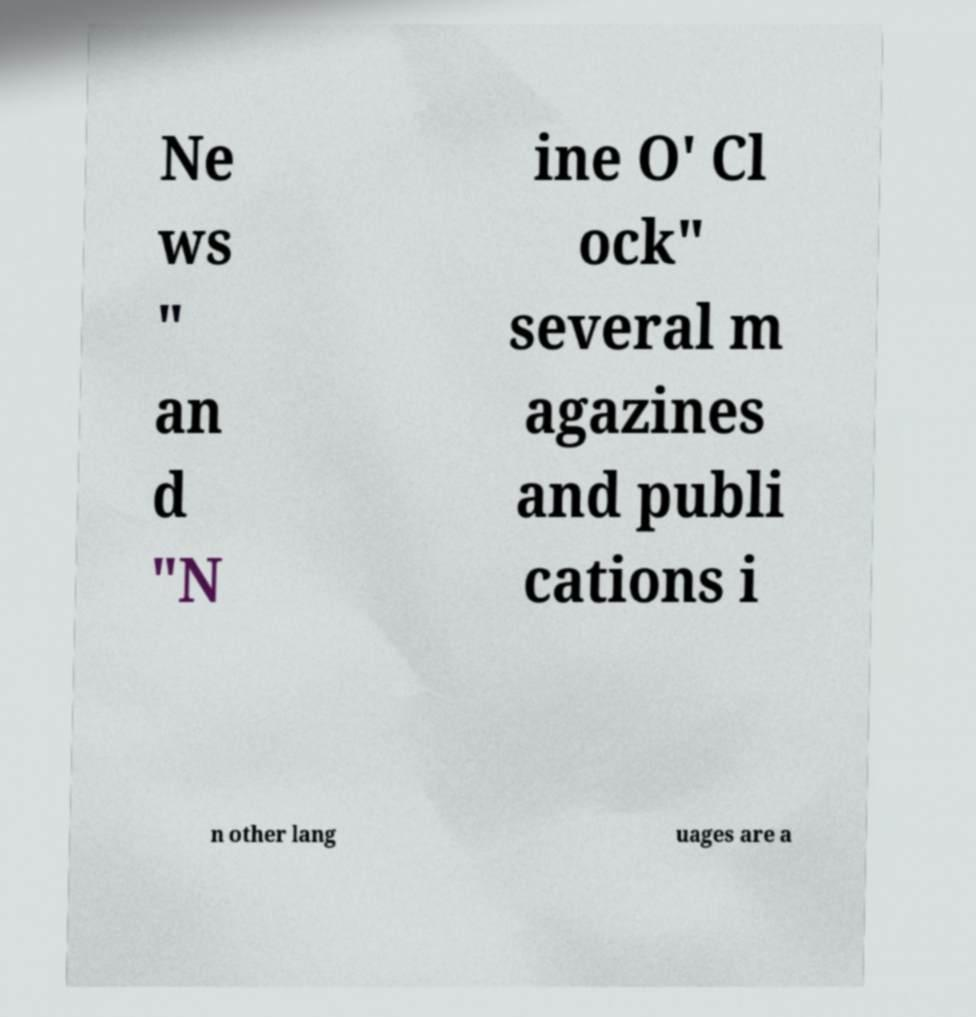Please read and relay the text visible in this image. What does it say? Ne ws " an d "N ine O' Cl ock" several m agazines and publi cations i n other lang uages are a 